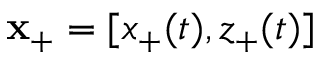Convert formula to latex. <formula><loc_0><loc_0><loc_500><loc_500>x _ { + } = [ x _ { + } ( t ) , z _ { + } ( t ) ]</formula> 